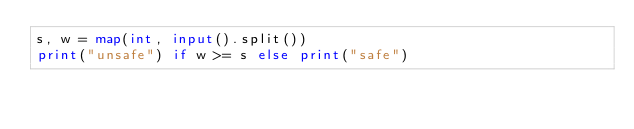Convert code to text. <code><loc_0><loc_0><loc_500><loc_500><_Python_>s, w = map(int, input().split())
print("unsafe") if w >= s else print("safe")</code> 